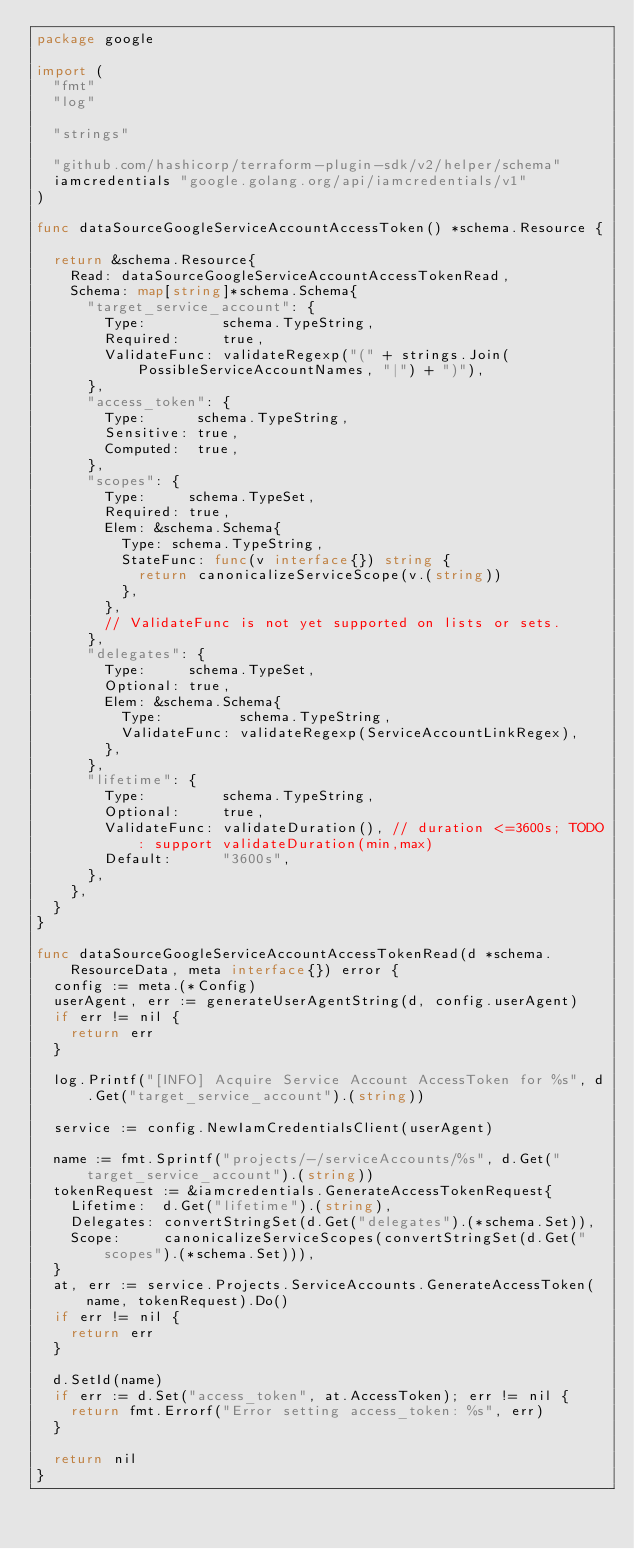Convert code to text. <code><loc_0><loc_0><loc_500><loc_500><_Go_>package google

import (
	"fmt"
	"log"

	"strings"

	"github.com/hashicorp/terraform-plugin-sdk/v2/helper/schema"
	iamcredentials "google.golang.org/api/iamcredentials/v1"
)

func dataSourceGoogleServiceAccountAccessToken() *schema.Resource {

	return &schema.Resource{
		Read: dataSourceGoogleServiceAccountAccessTokenRead,
		Schema: map[string]*schema.Schema{
			"target_service_account": {
				Type:         schema.TypeString,
				Required:     true,
				ValidateFunc: validateRegexp("(" + strings.Join(PossibleServiceAccountNames, "|") + ")"),
			},
			"access_token": {
				Type:      schema.TypeString,
				Sensitive: true,
				Computed:  true,
			},
			"scopes": {
				Type:     schema.TypeSet,
				Required: true,
				Elem: &schema.Schema{
					Type: schema.TypeString,
					StateFunc: func(v interface{}) string {
						return canonicalizeServiceScope(v.(string))
					},
				},
				// ValidateFunc is not yet supported on lists or sets.
			},
			"delegates": {
				Type:     schema.TypeSet,
				Optional: true,
				Elem: &schema.Schema{
					Type:         schema.TypeString,
					ValidateFunc: validateRegexp(ServiceAccountLinkRegex),
				},
			},
			"lifetime": {
				Type:         schema.TypeString,
				Optional:     true,
				ValidateFunc: validateDuration(), // duration <=3600s; TODO: support validateDuration(min,max)
				Default:      "3600s",
			},
		},
	}
}

func dataSourceGoogleServiceAccountAccessTokenRead(d *schema.ResourceData, meta interface{}) error {
	config := meta.(*Config)
	userAgent, err := generateUserAgentString(d, config.userAgent)
	if err != nil {
		return err
	}

	log.Printf("[INFO] Acquire Service Account AccessToken for %s", d.Get("target_service_account").(string))

	service := config.NewIamCredentialsClient(userAgent)

	name := fmt.Sprintf("projects/-/serviceAccounts/%s", d.Get("target_service_account").(string))
	tokenRequest := &iamcredentials.GenerateAccessTokenRequest{
		Lifetime:  d.Get("lifetime").(string),
		Delegates: convertStringSet(d.Get("delegates").(*schema.Set)),
		Scope:     canonicalizeServiceScopes(convertStringSet(d.Get("scopes").(*schema.Set))),
	}
	at, err := service.Projects.ServiceAccounts.GenerateAccessToken(name, tokenRequest).Do()
	if err != nil {
		return err
	}

	d.SetId(name)
	if err := d.Set("access_token", at.AccessToken); err != nil {
		return fmt.Errorf("Error setting access_token: %s", err)
	}

	return nil
}
</code> 